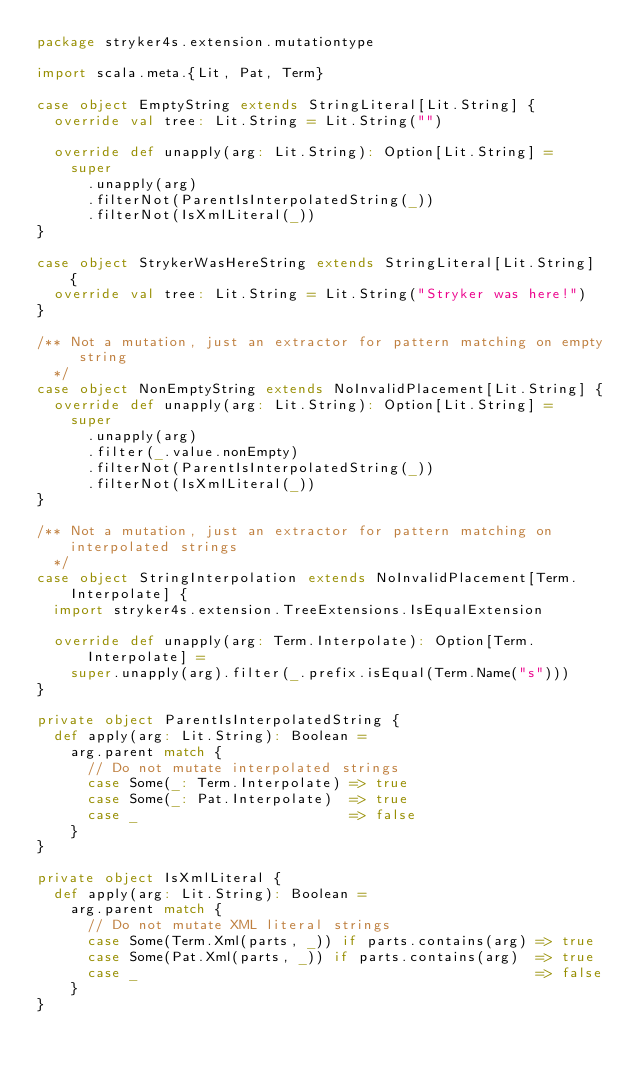<code> <loc_0><loc_0><loc_500><loc_500><_Scala_>package stryker4s.extension.mutationtype

import scala.meta.{Lit, Pat, Term}

case object EmptyString extends StringLiteral[Lit.String] {
  override val tree: Lit.String = Lit.String("")

  override def unapply(arg: Lit.String): Option[Lit.String] =
    super
      .unapply(arg)
      .filterNot(ParentIsInterpolatedString(_))
      .filterNot(IsXmlLiteral(_))
}

case object StrykerWasHereString extends StringLiteral[Lit.String] {
  override val tree: Lit.String = Lit.String("Stryker was here!")
}

/** Not a mutation, just an extractor for pattern matching on empty string
  */
case object NonEmptyString extends NoInvalidPlacement[Lit.String] {
  override def unapply(arg: Lit.String): Option[Lit.String] =
    super
      .unapply(arg)
      .filter(_.value.nonEmpty)
      .filterNot(ParentIsInterpolatedString(_))
      .filterNot(IsXmlLiteral(_))
}

/** Not a mutation, just an extractor for pattern matching on interpolated strings
  */
case object StringInterpolation extends NoInvalidPlacement[Term.Interpolate] {
  import stryker4s.extension.TreeExtensions.IsEqualExtension

  override def unapply(arg: Term.Interpolate): Option[Term.Interpolate] =
    super.unapply(arg).filter(_.prefix.isEqual(Term.Name("s")))
}

private object ParentIsInterpolatedString {
  def apply(arg: Lit.String): Boolean =
    arg.parent match {
      // Do not mutate interpolated strings
      case Some(_: Term.Interpolate) => true
      case Some(_: Pat.Interpolate)  => true
      case _                         => false
    }
}

private object IsXmlLiteral {
  def apply(arg: Lit.String): Boolean =
    arg.parent match {
      // Do not mutate XML literal strings
      case Some(Term.Xml(parts, _)) if parts.contains(arg) => true
      case Some(Pat.Xml(parts, _)) if parts.contains(arg)  => true
      case _                                               => false
    }
}
</code> 